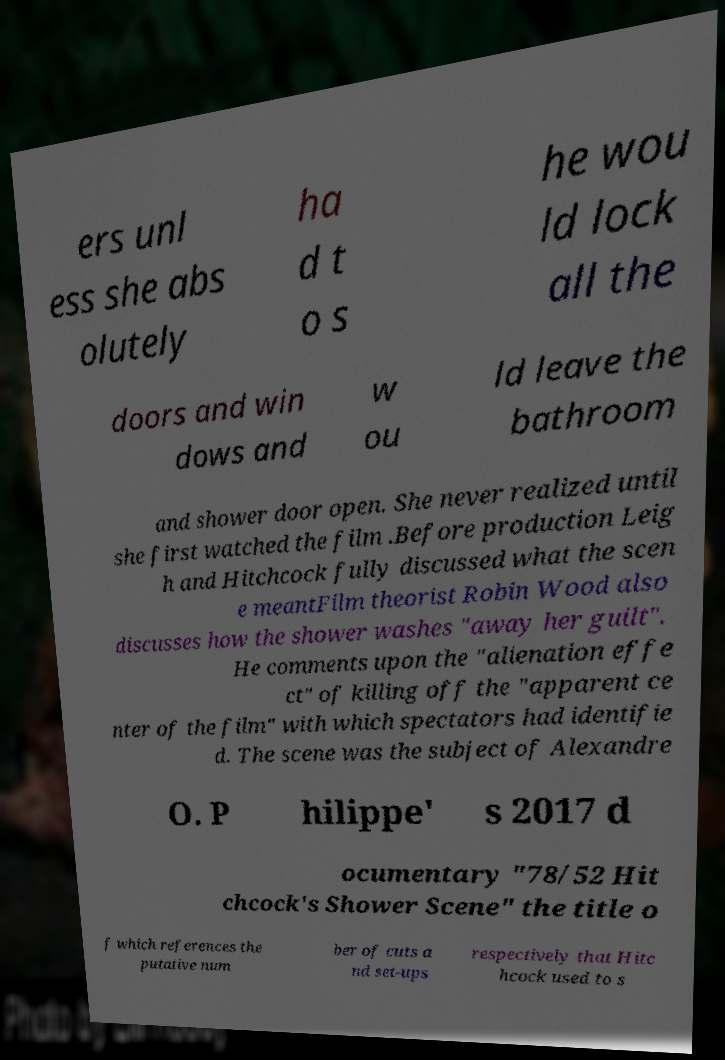I need the written content from this picture converted into text. Can you do that? ers unl ess she abs olutely ha d t o s he wou ld lock all the doors and win dows and w ou ld leave the bathroom and shower door open. She never realized until she first watched the film .Before production Leig h and Hitchcock fully discussed what the scen e meantFilm theorist Robin Wood also discusses how the shower washes "away her guilt". He comments upon the "alienation effe ct" of killing off the "apparent ce nter of the film" with which spectators had identifie d. The scene was the subject of Alexandre O. P hilippe' s 2017 d ocumentary "78/52 Hit chcock's Shower Scene" the title o f which references the putative num ber of cuts a nd set-ups respectively that Hitc hcock used to s 